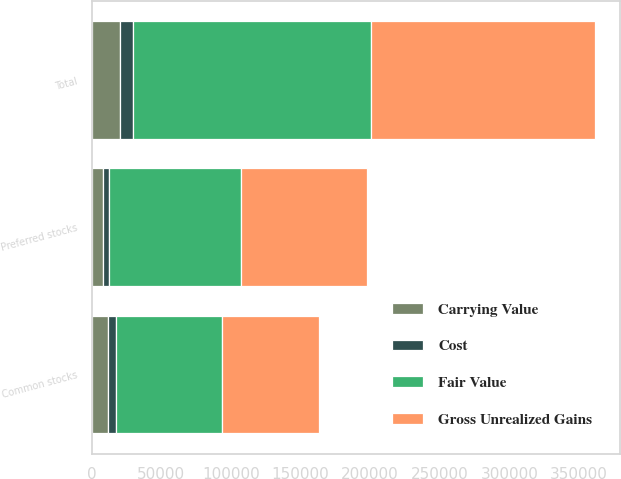Convert chart to OTSL. <chart><loc_0><loc_0><loc_500><loc_500><stacked_bar_chart><ecel><fcel>Common stocks<fcel>Preferred stocks<fcel>Total<nl><fcel>Gross Unrealized Gains<fcel>69870<fcel>90425<fcel>160295<nl><fcel>Carrying Value<fcel>11929<fcel>8385<fcel>20314<nl><fcel>Cost<fcel>5453<fcel>4165<fcel>9618<nl><fcel>Fair Value<fcel>76346<fcel>94645<fcel>170991<nl></chart> 